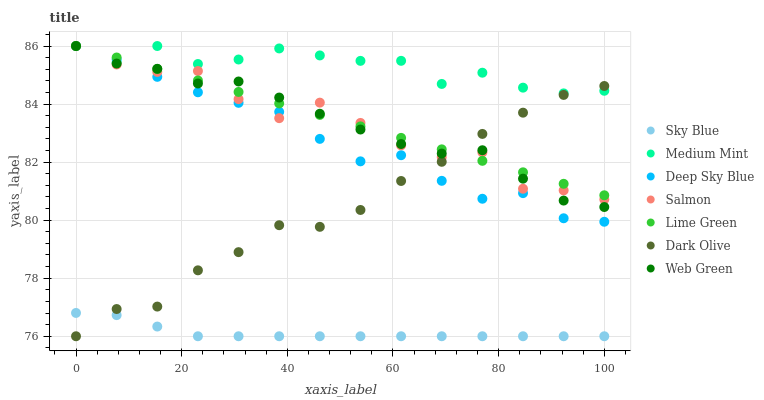Does Sky Blue have the minimum area under the curve?
Answer yes or no. Yes. Does Medium Mint have the maximum area under the curve?
Answer yes or no. Yes. Does Dark Olive have the minimum area under the curve?
Answer yes or no. No. Does Dark Olive have the maximum area under the curve?
Answer yes or no. No. Is Lime Green the smoothest?
Answer yes or no. Yes. Is Salmon the roughest?
Answer yes or no. Yes. Is Dark Olive the smoothest?
Answer yes or no. No. Is Dark Olive the roughest?
Answer yes or no. No. Does Dark Olive have the lowest value?
Answer yes or no. Yes. Does Salmon have the lowest value?
Answer yes or no. No. Does Lime Green have the highest value?
Answer yes or no. Yes. Does Dark Olive have the highest value?
Answer yes or no. No. Is Sky Blue less than Salmon?
Answer yes or no. Yes. Is Web Green greater than Sky Blue?
Answer yes or no. Yes. Does Deep Sky Blue intersect Salmon?
Answer yes or no. Yes. Is Deep Sky Blue less than Salmon?
Answer yes or no. No. Is Deep Sky Blue greater than Salmon?
Answer yes or no. No. Does Sky Blue intersect Salmon?
Answer yes or no. No. 